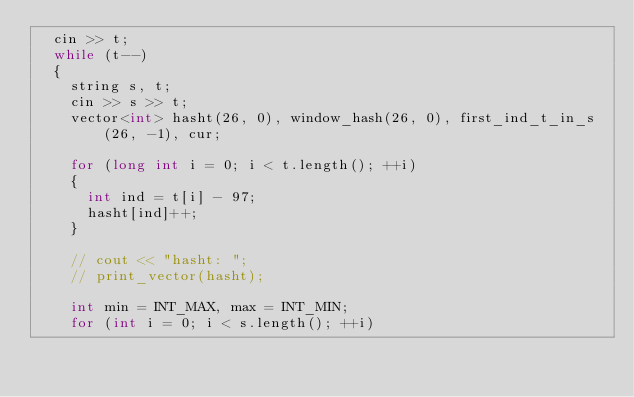Convert code to text. <code><loc_0><loc_0><loc_500><loc_500><_C++_>	cin >> t;
	while (t--)
	{
		string s, t;
		cin >> s >> t;
		vector<int> hasht(26, 0), window_hash(26, 0), first_ind_t_in_s(26, -1), cur;

		for (long int i = 0; i < t.length(); ++i)
		{
			int ind = t[i] - 97;
			hasht[ind]++;
		}

		// cout << "hasht: ";
		// print_vector(hasht);

		int min = INT_MAX, max = INT_MIN;
		for (int i = 0; i < s.length(); ++i)</code> 